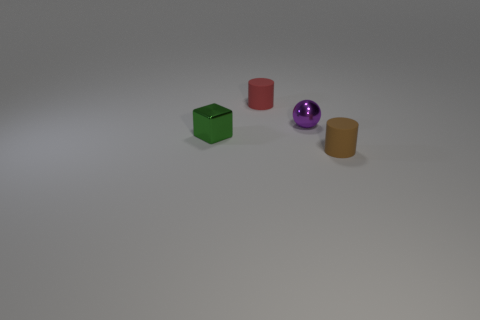Add 2 small green metal things. How many objects exist? 6 Subtract all cubes. How many objects are left? 3 Add 2 tiny purple balls. How many tiny purple balls are left? 3 Add 2 small purple metallic balls. How many small purple metallic balls exist? 3 Subtract all red cylinders. How many cylinders are left? 1 Subtract 1 red cylinders. How many objects are left? 3 Subtract 1 cubes. How many cubes are left? 0 Subtract all gray cylinders. Subtract all purple blocks. How many cylinders are left? 2 Subtract all cyan cylinders. How many brown cubes are left? 0 Subtract all gray metallic cylinders. Subtract all brown objects. How many objects are left? 3 